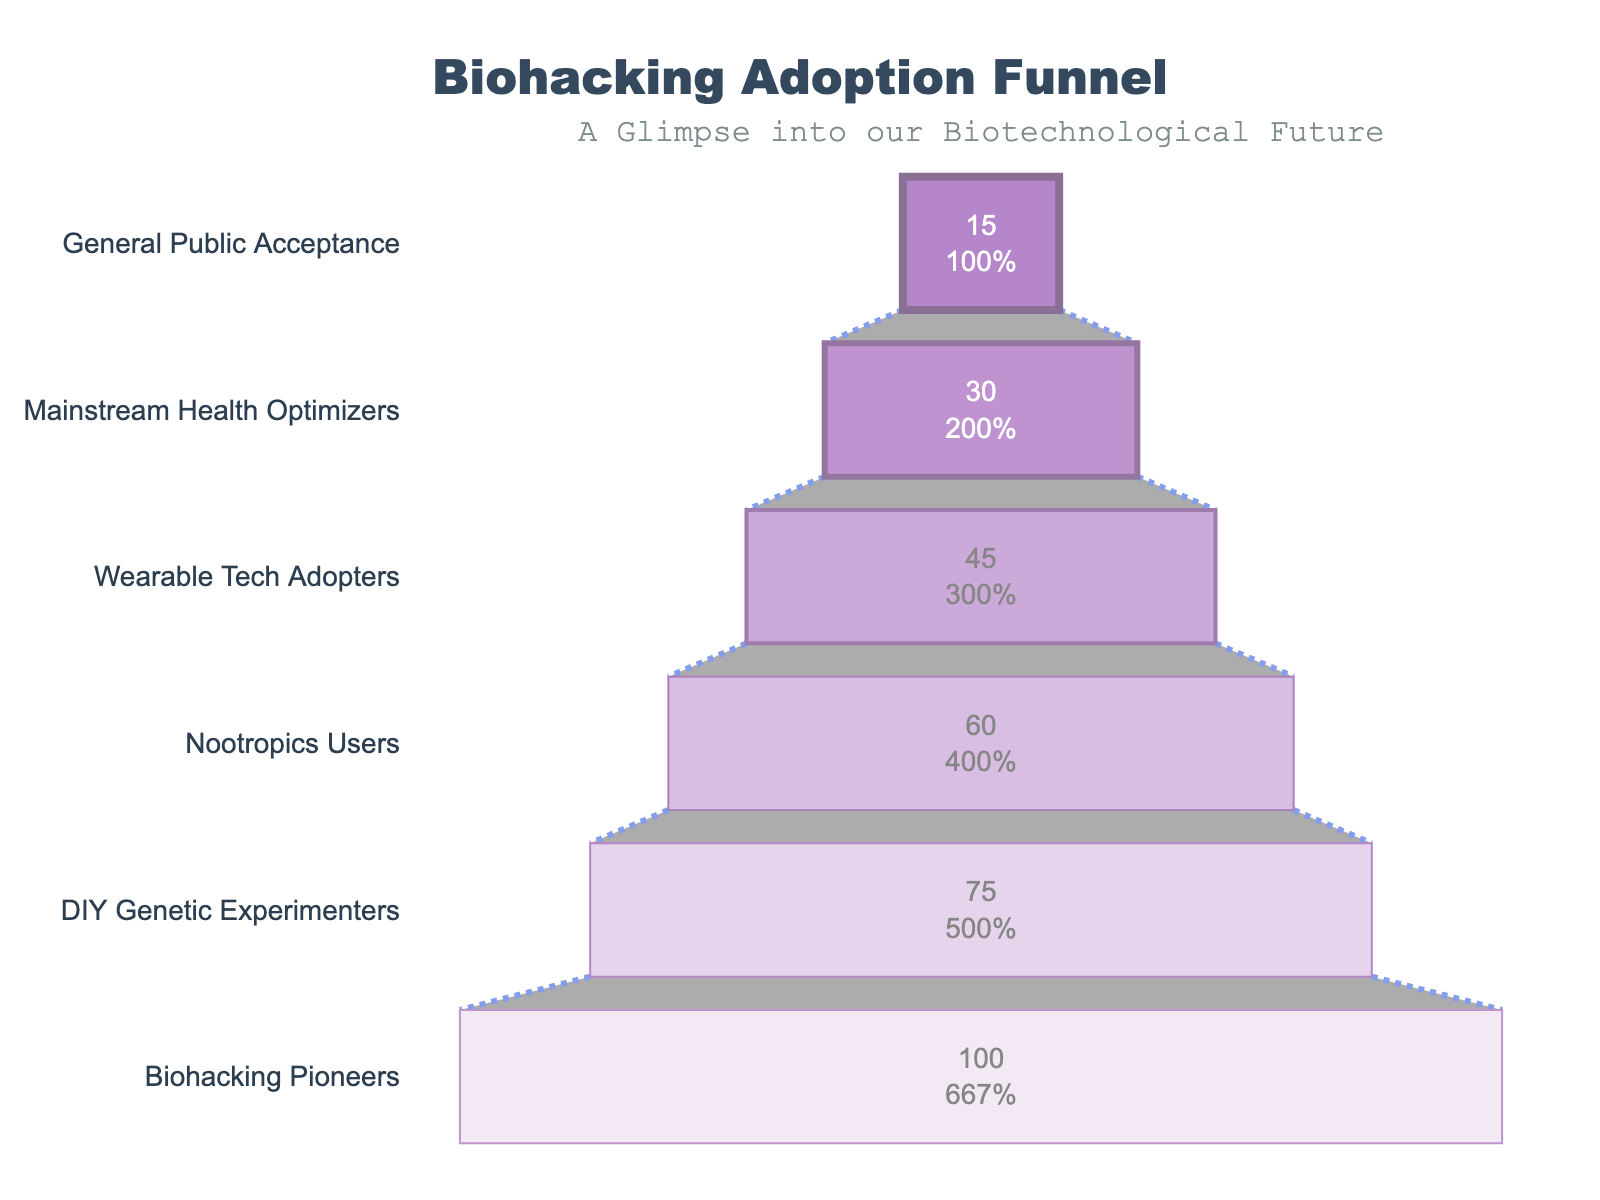What's the title of the chart? The title is located at the top of the chart. It is usually displayed prominently and is meant to summarize the main subject of the visualization.
Answer: "Biohacking Adoption Funnel" How many stages are represented in this funnel chart? Count the distinct entries listed in the 'Stage' column. Each stage represents a different step in the adoption process.
Answer: 6 What percentage of the general public has accepted biohacking? Look for the 'General Public Acceptance' stage and find the associated percentage. It's shown at the bottom of the chart.
Answer: 15% What is the difference in percentage between 'Biohacking Pioneers' and 'Wearable Tech Adopters'? Subtract the percentage of 'Wearable Tech Adopters' from 'Biohacking Pioneers' to find the difference. 'Biohacking Pioneers' is 100%, and 'Wearable Tech Adopters' is 45%. 100% - 45% = 55%.
Answer: 55% Which stage shows a greater adoption: 'DIY Genetic Experimenters' or 'Mainstream Health Optimizers'? Compare the percentages of 'DIY Genetic Experimenters' (75%) and 'Mainstream Health Optimizers' (30%). 75% is greater than 30%.
Answer: DIY Genetic Experimenters At what percentage does the 'Nootropics Users' stage stand? Locate the 'Nootropics Users' stage and read the percentage directly next to it.
Answer: 60% What is the combined percentage of 'Nootropics Users' and 'Wearable Tech Adopters'? Add the percentages of the two stages together. 'Nootropics Users' is 60%, and 'Wearable Tech Adopters' is 45%. 60% + 45% = 105%.
Answer: 105% Which group follows 'DIY Genetic Experimenters' in the adoption funnel? Identify the stage directly below 'DIY Genetic Experimenters' when the data is reversed for the funnel chart.
Answer: Nootropics Users What is the decline in percentage from 'Nootropics Users' to 'Mainstream Health Optimizers'? Subtract the percentage of 'Mainstream Health Optimizers' from 'Nootropics Users'. 'Nootropics Users' is 60%, and 'Mainstream Health Optimizers' is 30%. 60% - 30% = 30%.
Answer: 30% How does the funnel visually represent the decreasing adoption rates? The chart uses narrowing sections with decreasing widths to indicate reduced percentages at each subsequent stage, visually demonstrating the drop-off in adoption.
Answer: Narrowing sections 